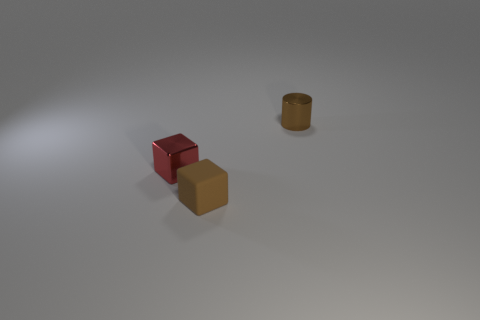Add 3 tiny blue things. How many objects exist? 6 Subtract all cubes. How many objects are left? 1 Add 3 small metal blocks. How many small metal blocks exist? 4 Subtract 0 red spheres. How many objects are left? 3 Subtract all large purple shiny objects. Subtract all metal cylinders. How many objects are left? 2 Add 2 tiny matte cubes. How many tiny matte cubes are left? 3 